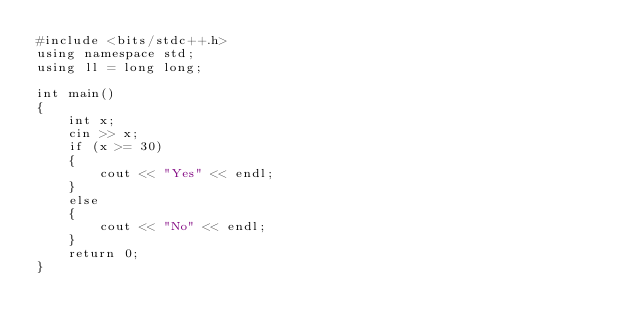<code> <loc_0><loc_0><loc_500><loc_500><_C++_>#include <bits/stdc++.h>
using namespace std;
using ll = long long;

int main()
{
    int x;
    cin >> x;
    if (x >= 30)
    {
        cout << "Yes" << endl;
    }
    else
    {
        cout << "No" << endl;
    }
    return 0;
}</code> 